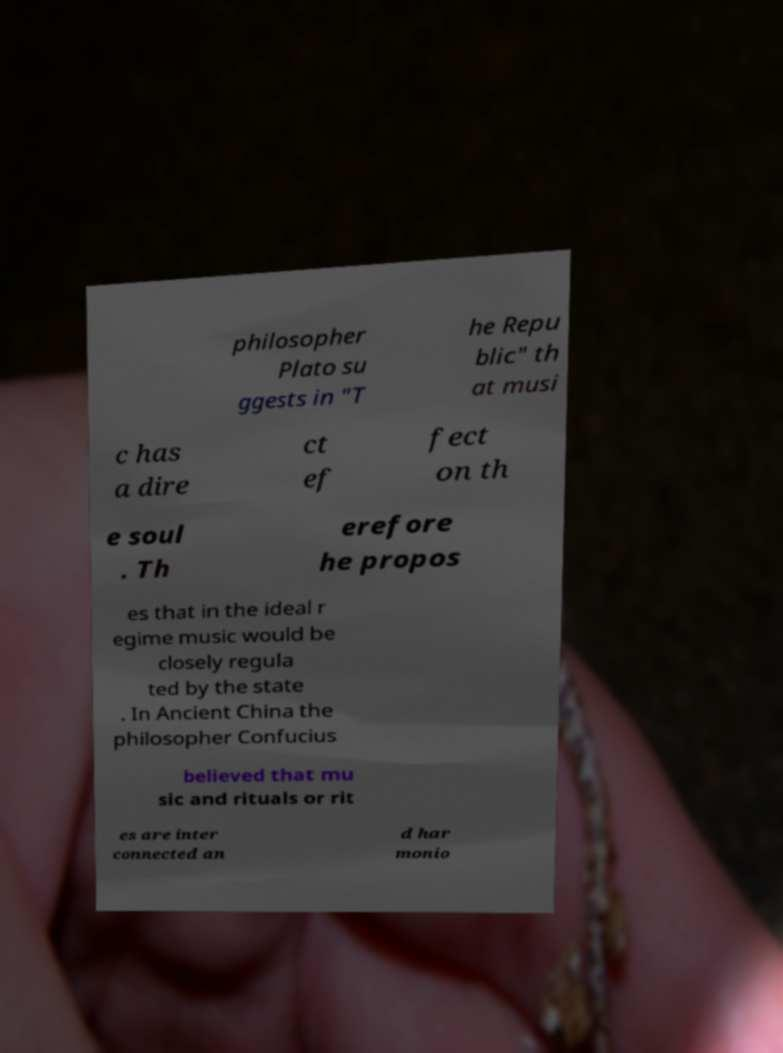Could you assist in decoding the text presented in this image and type it out clearly? philosopher Plato su ggests in "T he Repu blic" th at musi c has a dire ct ef fect on th e soul . Th erefore he propos es that in the ideal r egime music would be closely regula ted by the state . In Ancient China the philosopher Confucius believed that mu sic and rituals or rit es are inter connected an d har monio 